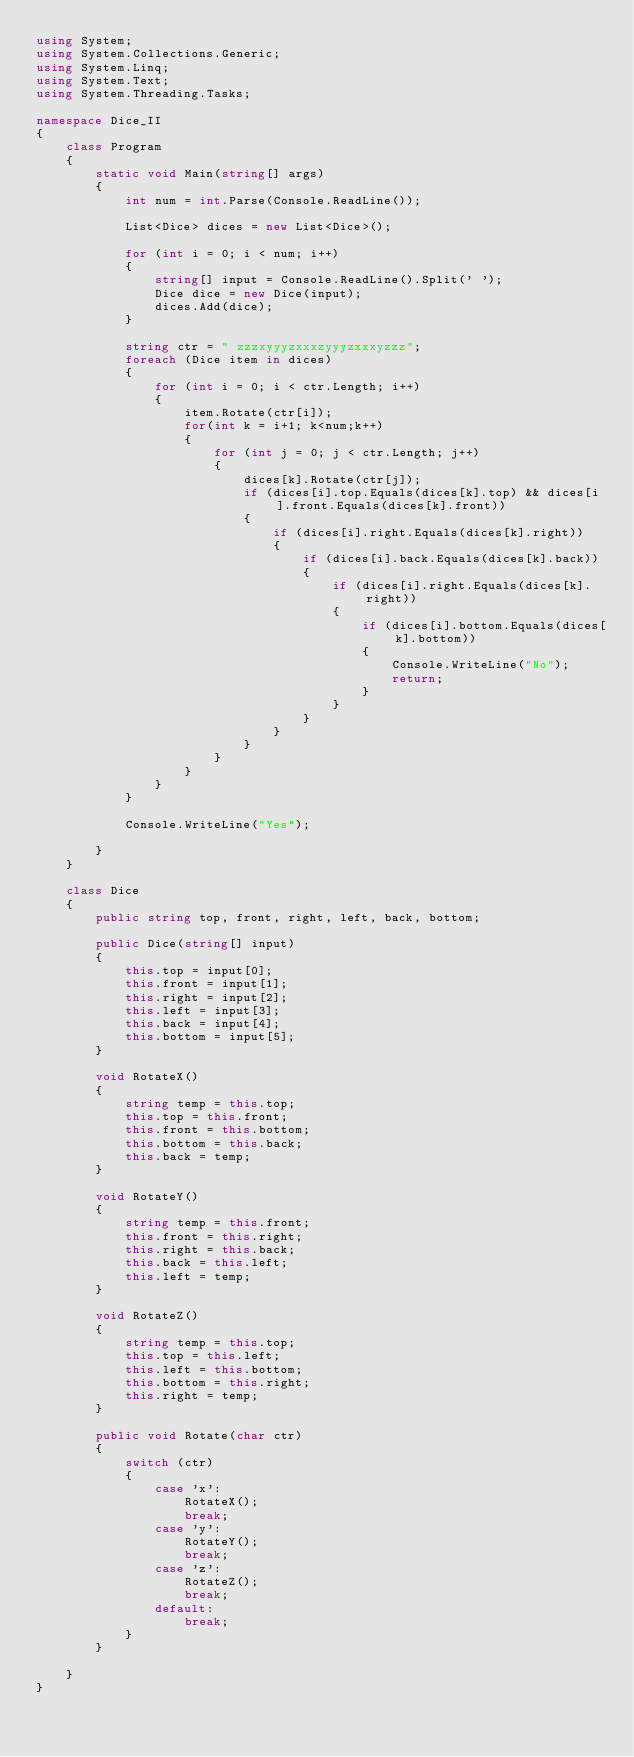<code> <loc_0><loc_0><loc_500><loc_500><_C#_>using System;
using System.Collections.Generic;
using System.Linq;
using System.Text;
using System.Threading.Tasks;

namespace Dice_II
{
    class Program
    {
        static void Main(string[] args)
        {
            int num = int.Parse(Console.ReadLine());

            List<Dice> dices = new List<Dice>();

            for (int i = 0; i < num; i++)
            {
                string[] input = Console.ReadLine().Split(' ');
                Dice dice = new Dice(input);
                dices.Add(dice);
            }

            string ctr = " zzzxyyyzxxxzyyyzxxxyzzz";
            foreach (Dice item in dices)
            { 
                for (int i = 0; i < ctr.Length; i++)
                {
                    item.Rotate(ctr[i]);
                    for(int k = i+1; k<num;k++)
                    {
                        for (int j = 0; j < ctr.Length; j++)
                        {
                            dices[k].Rotate(ctr[j]);
                            if (dices[i].top.Equals(dices[k].top) && dices[i].front.Equals(dices[k].front))
                            {
                                if (dices[i].right.Equals(dices[k].right))
                                {
                                    if (dices[i].back.Equals(dices[k].back))
                                    {
                                        if (dices[i].right.Equals(dices[k].right))
                                        {
                                            if (dices[i].bottom.Equals(dices[k].bottom))
                                            {
                                                Console.WriteLine("No");
                                                return;
                                            }
                                        }
                                    }
                                }
                            }
                        }
                    }
                }
            }

            Console.WriteLine("Yes");
            
        }
    }

    class Dice
    {
        public string top, front, right, left, back, bottom;

        public Dice(string[] input)
        {
            this.top = input[0];
            this.front = input[1];
            this.right = input[2];
            this.left = input[3];
            this.back = input[4];
            this.bottom = input[5];
        }

        void RotateX()
        {
            string temp = this.top;
            this.top = this.front;
            this.front = this.bottom;
            this.bottom = this.back;
            this.back = temp;
        }

        void RotateY()
        {
            string temp = this.front;
            this.front = this.right;
            this.right = this.back;
            this.back = this.left;
            this.left = temp;
        }

        void RotateZ()
        {
            string temp = this.top;
            this.top = this.left;
            this.left = this.bottom;
            this.bottom = this.right;
            this.right = temp;
        }

        public void Rotate(char ctr)
        {
            switch (ctr)
            {
                case 'x':
                    RotateX();
                    break;
                case 'y':
                    RotateY();
                    break;
                case 'z':
                    RotateZ();
                    break;
                default:
                    break;
            }
        }

    }
}

</code> 